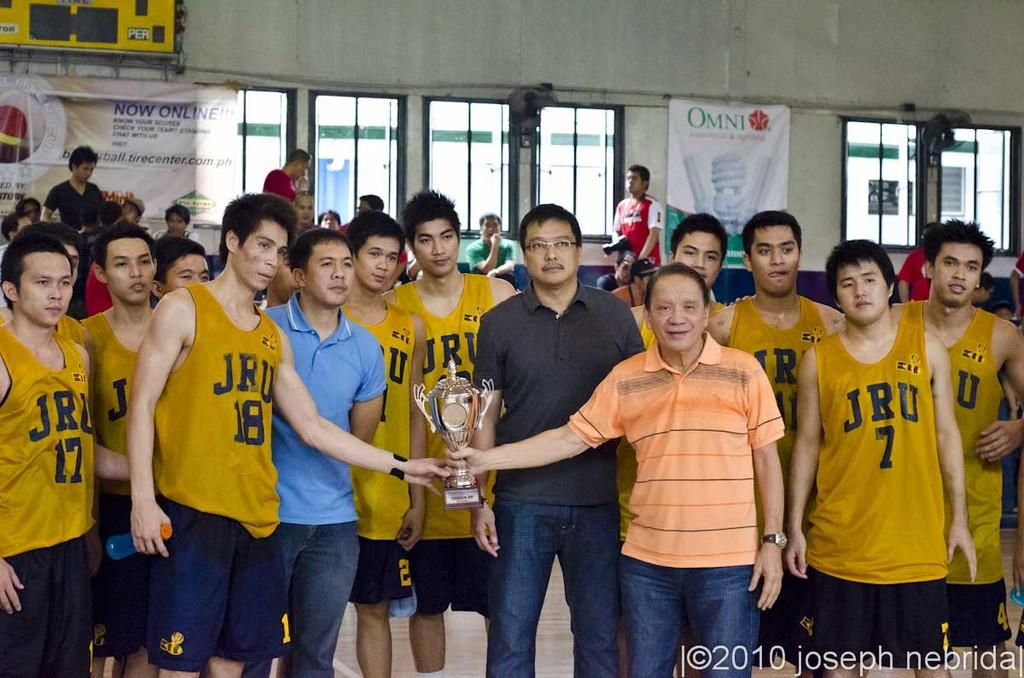<image>
Share a concise interpretation of the image provided. A bunch of sports players who are all wearing vests with JRU on them. 